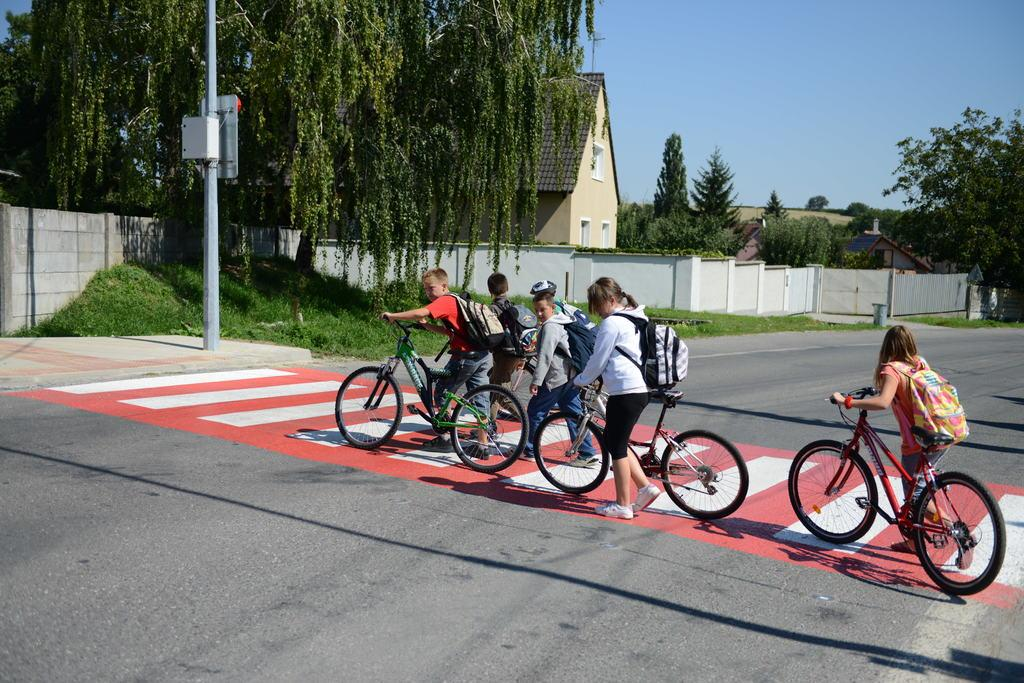How many people are in the image? There are people in the image, but the exact number is not specified. What are the people holding in the image? The people are holding bicycles in the image. What are the people wearing in the image? The people are wearing bags in the image. What can be seen in the background of the image? In the background of the image, there are houses, walls, grass, a pole, and trees. What is the color of the sky in the image? The sky is blue in the image. What is on the pole in the background of the image? There is a box and a board on the pole in the background of the image. Is there a person swinging on a roof in the image? No, there is no person swinging on a roof in the image. 